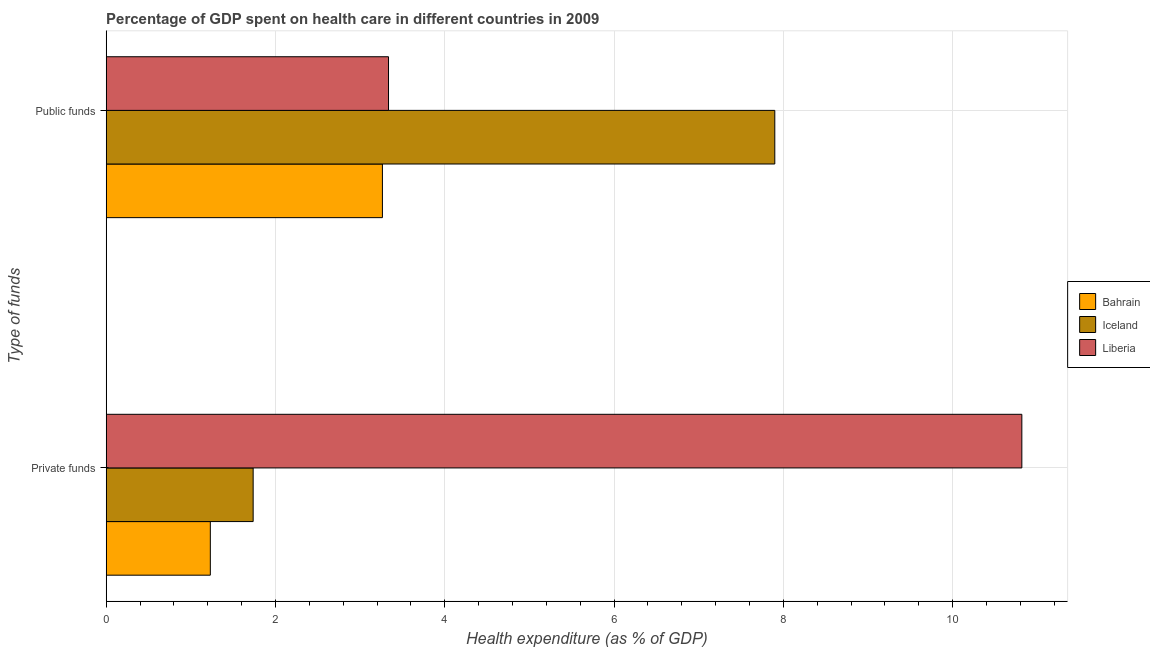How many groups of bars are there?
Offer a terse response. 2. Are the number of bars per tick equal to the number of legend labels?
Make the answer very short. Yes. How many bars are there on the 1st tick from the top?
Ensure brevity in your answer.  3. How many bars are there on the 1st tick from the bottom?
Make the answer very short. 3. What is the label of the 2nd group of bars from the top?
Provide a succinct answer. Private funds. What is the amount of private funds spent in healthcare in Bahrain?
Your answer should be compact. 1.23. Across all countries, what is the maximum amount of private funds spent in healthcare?
Make the answer very short. 10.82. Across all countries, what is the minimum amount of private funds spent in healthcare?
Your answer should be compact. 1.23. In which country was the amount of private funds spent in healthcare minimum?
Your answer should be compact. Bahrain. What is the total amount of public funds spent in healthcare in the graph?
Offer a very short reply. 14.5. What is the difference between the amount of private funds spent in healthcare in Iceland and that in Bahrain?
Offer a terse response. 0.51. What is the difference between the amount of public funds spent in healthcare in Iceland and the amount of private funds spent in healthcare in Liberia?
Your response must be concise. -2.92. What is the average amount of private funds spent in healthcare per country?
Make the answer very short. 4.59. What is the difference between the amount of private funds spent in healthcare and amount of public funds spent in healthcare in Iceland?
Make the answer very short. -6.16. What is the ratio of the amount of public funds spent in healthcare in Iceland to that in Bahrain?
Your answer should be very brief. 2.42. Is the amount of public funds spent in healthcare in Bahrain less than that in Liberia?
Give a very brief answer. Yes. What does the 3rd bar from the top in Public funds represents?
Your response must be concise. Bahrain. What does the 2nd bar from the bottom in Private funds represents?
Provide a succinct answer. Iceland. How many bars are there?
Make the answer very short. 6. Are all the bars in the graph horizontal?
Offer a very short reply. Yes. How many countries are there in the graph?
Your answer should be very brief. 3. Where does the legend appear in the graph?
Give a very brief answer. Center right. How many legend labels are there?
Keep it short and to the point. 3. What is the title of the graph?
Your answer should be compact. Percentage of GDP spent on health care in different countries in 2009. What is the label or title of the X-axis?
Ensure brevity in your answer.  Health expenditure (as % of GDP). What is the label or title of the Y-axis?
Give a very brief answer. Type of funds. What is the Health expenditure (as % of GDP) of Bahrain in Private funds?
Provide a succinct answer. 1.23. What is the Health expenditure (as % of GDP) of Iceland in Private funds?
Give a very brief answer. 1.74. What is the Health expenditure (as % of GDP) in Liberia in Private funds?
Your answer should be very brief. 10.82. What is the Health expenditure (as % of GDP) in Bahrain in Public funds?
Offer a very short reply. 3.26. What is the Health expenditure (as % of GDP) in Iceland in Public funds?
Provide a succinct answer. 7.9. What is the Health expenditure (as % of GDP) of Liberia in Public funds?
Keep it short and to the point. 3.34. Across all Type of funds, what is the maximum Health expenditure (as % of GDP) of Bahrain?
Keep it short and to the point. 3.26. Across all Type of funds, what is the maximum Health expenditure (as % of GDP) in Iceland?
Your answer should be compact. 7.9. Across all Type of funds, what is the maximum Health expenditure (as % of GDP) in Liberia?
Your response must be concise. 10.82. Across all Type of funds, what is the minimum Health expenditure (as % of GDP) of Bahrain?
Your response must be concise. 1.23. Across all Type of funds, what is the minimum Health expenditure (as % of GDP) in Iceland?
Your answer should be very brief. 1.74. Across all Type of funds, what is the minimum Health expenditure (as % of GDP) in Liberia?
Provide a succinct answer. 3.34. What is the total Health expenditure (as % of GDP) in Bahrain in the graph?
Make the answer very short. 4.49. What is the total Health expenditure (as % of GDP) of Iceland in the graph?
Provide a succinct answer. 9.64. What is the total Health expenditure (as % of GDP) of Liberia in the graph?
Make the answer very short. 14.15. What is the difference between the Health expenditure (as % of GDP) in Bahrain in Private funds and that in Public funds?
Give a very brief answer. -2.03. What is the difference between the Health expenditure (as % of GDP) in Iceland in Private funds and that in Public funds?
Ensure brevity in your answer.  -6.16. What is the difference between the Health expenditure (as % of GDP) of Liberia in Private funds and that in Public funds?
Provide a short and direct response. 7.48. What is the difference between the Health expenditure (as % of GDP) in Bahrain in Private funds and the Health expenditure (as % of GDP) in Iceland in Public funds?
Make the answer very short. -6.67. What is the difference between the Health expenditure (as % of GDP) of Bahrain in Private funds and the Health expenditure (as % of GDP) of Liberia in Public funds?
Offer a very short reply. -2.11. What is the difference between the Health expenditure (as % of GDP) of Iceland in Private funds and the Health expenditure (as % of GDP) of Liberia in Public funds?
Keep it short and to the point. -1.6. What is the average Health expenditure (as % of GDP) of Bahrain per Type of funds?
Give a very brief answer. 2.25. What is the average Health expenditure (as % of GDP) in Iceland per Type of funds?
Give a very brief answer. 4.82. What is the average Health expenditure (as % of GDP) in Liberia per Type of funds?
Keep it short and to the point. 7.08. What is the difference between the Health expenditure (as % of GDP) of Bahrain and Health expenditure (as % of GDP) of Iceland in Private funds?
Give a very brief answer. -0.51. What is the difference between the Health expenditure (as % of GDP) of Bahrain and Health expenditure (as % of GDP) of Liberia in Private funds?
Make the answer very short. -9.59. What is the difference between the Health expenditure (as % of GDP) of Iceland and Health expenditure (as % of GDP) of Liberia in Private funds?
Your answer should be very brief. -9.08. What is the difference between the Health expenditure (as % of GDP) of Bahrain and Health expenditure (as % of GDP) of Iceland in Public funds?
Make the answer very short. -4.64. What is the difference between the Health expenditure (as % of GDP) of Bahrain and Health expenditure (as % of GDP) of Liberia in Public funds?
Make the answer very short. -0.07. What is the difference between the Health expenditure (as % of GDP) of Iceland and Health expenditure (as % of GDP) of Liberia in Public funds?
Keep it short and to the point. 4.56. What is the ratio of the Health expenditure (as % of GDP) of Bahrain in Private funds to that in Public funds?
Provide a succinct answer. 0.38. What is the ratio of the Health expenditure (as % of GDP) of Iceland in Private funds to that in Public funds?
Provide a short and direct response. 0.22. What is the ratio of the Health expenditure (as % of GDP) of Liberia in Private funds to that in Public funds?
Your answer should be compact. 3.24. What is the difference between the highest and the second highest Health expenditure (as % of GDP) in Bahrain?
Ensure brevity in your answer.  2.03. What is the difference between the highest and the second highest Health expenditure (as % of GDP) in Iceland?
Your answer should be very brief. 6.16. What is the difference between the highest and the second highest Health expenditure (as % of GDP) of Liberia?
Provide a succinct answer. 7.48. What is the difference between the highest and the lowest Health expenditure (as % of GDP) of Bahrain?
Provide a short and direct response. 2.03. What is the difference between the highest and the lowest Health expenditure (as % of GDP) of Iceland?
Your response must be concise. 6.16. What is the difference between the highest and the lowest Health expenditure (as % of GDP) in Liberia?
Offer a very short reply. 7.48. 